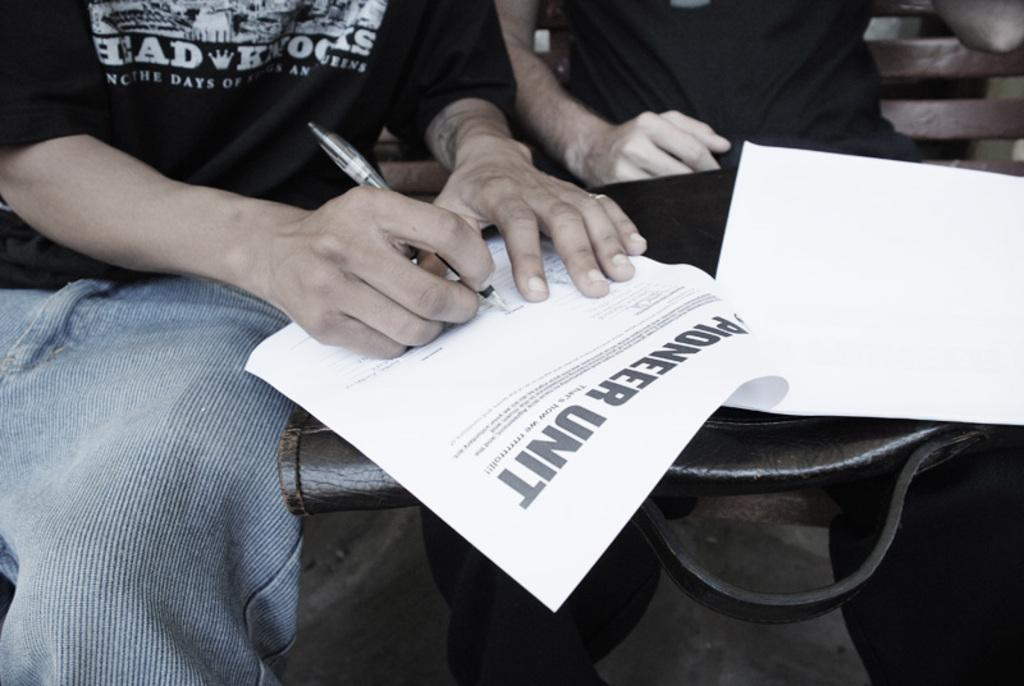What objects can be seen in the image? There are papers in the image, and a person is writing on a paper. How many people are present in the image? There are two people in the image. What is the second person holding? The second person is holding a bag on his lap. What type of voice can be heard coming from the person writing in the image? There is no indication of any sound or voice in the image, as it only shows people and papers. 